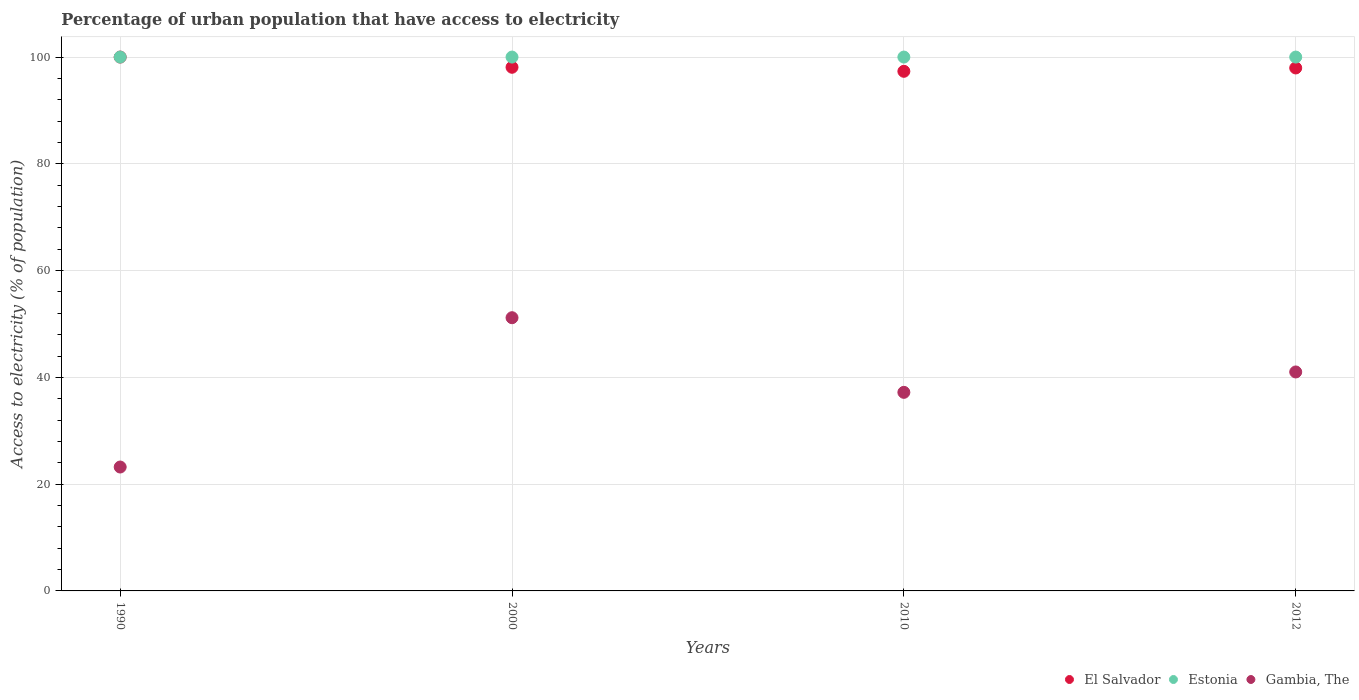Is the number of dotlines equal to the number of legend labels?
Your answer should be very brief. Yes. What is the percentage of urban population that have access to electricity in Gambia, The in 2010?
Provide a succinct answer. 37.2. Across all years, what is the maximum percentage of urban population that have access to electricity in Estonia?
Ensure brevity in your answer.  100. Across all years, what is the minimum percentage of urban population that have access to electricity in El Salvador?
Give a very brief answer. 97.33. In which year was the percentage of urban population that have access to electricity in El Salvador maximum?
Keep it short and to the point. 1990. In which year was the percentage of urban population that have access to electricity in El Salvador minimum?
Your response must be concise. 2010. What is the total percentage of urban population that have access to electricity in El Salvador in the graph?
Your response must be concise. 393.39. What is the difference between the percentage of urban population that have access to electricity in El Salvador in 2000 and that in 2012?
Offer a terse response. 0.13. What is the difference between the percentage of urban population that have access to electricity in Gambia, The in 1990 and the percentage of urban population that have access to electricity in El Salvador in 2000?
Offer a terse response. -74.88. What is the average percentage of urban population that have access to electricity in El Salvador per year?
Your answer should be very brief. 98.35. In the year 2000, what is the difference between the percentage of urban population that have access to electricity in El Salvador and percentage of urban population that have access to electricity in Estonia?
Offer a terse response. -1.91. In how many years, is the percentage of urban population that have access to electricity in Gambia, The greater than 16 %?
Offer a very short reply. 4. What is the ratio of the percentage of urban population that have access to electricity in Estonia in 1990 to that in 2000?
Your answer should be very brief. 1. What is the difference between the highest and the lowest percentage of urban population that have access to electricity in El Salvador?
Your response must be concise. 2.67. In how many years, is the percentage of urban population that have access to electricity in Gambia, The greater than the average percentage of urban population that have access to electricity in Gambia, The taken over all years?
Provide a succinct answer. 2. Is the sum of the percentage of urban population that have access to electricity in El Salvador in 2000 and 2010 greater than the maximum percentage of urban population that have access to electricity in Estonia across all years?
Your answer should be compact. Yes. Is it the case that in every year, the sum of the percentage of urban population that have access to electricity in Estonia and percentage of urban population that have access to electricity in Gambia, The  is greater than the percentage of urban population that have access to electricity in El Salvador?
Make the answer very short. Yes. Is the percentage of urban population that have access to electricity in Estonia strictly greater than the percentage of urban population that have access to electricity in El Salvador over the years?
Keep it short and to the point. No. How many years are there in the graph?
Give a very brief answer. 4. What is the difference between two consecutive major ticks on the Y-axis?
Provide a succinct answer. 20. Are the values on the major ticks of Y-axis written in scientific E-notation?
Your response must be concise. No. Does the graph contain grids?
Give a very brief answer. Yes. How many legend labels are there?
Your response must be concise. 3. What is the title of the graph?
Make the answer very short. Percentage of urban population that have access to electricity. What is the label or title of the Y-axis?
Provide a succinct answer. Access to electricity (% of population). What is the Access to electricity (% of population) of Estonia in 1990?
Your response must be concise. 100. What is the Access to electricity (% of population) in Gambia, The in 1990?
Offer a very short reply. 23.21. What is the Access to electricity (% of population) of El Salvador in 2000?
Provide a succinct answer. 98.09. What is the Access to electricity (% of population) in Gambia, The in 2000?
Offer a terse response. 51.18. What is the Access to electricity (% of population) in El Salvador in 2010?
Give a very brief answer. 97.33. What is the Access to electricity (% of population) of Estonia in 2010?
Offer a very short reply. 100. What is the Access to electricity (% of population) of Gambia, The in 2010?
Your answer should be compact. 37.2. What is the Access to electricity (% of population) in El Salvador in 2012?
Keep it short and to the point. 97.96. What is the Access to electricity (% of population) in Gambia, The in 2012?
Offer a very short reply. 41.01. Across all years, what is the maximum Access to electricity (% of population) of Gambia, The?
Ensure brevity in your answer.  51.18. Across all years, what is the minimum Access to electricity (% of population) in El Salvador?
Provide a short and direct response. 97.33. Across all years, what is the minimum Access to electricity (% of population) of Gambia, The?
Provide a short and direct response. 23.21. What is the total Access to electricity (% of population) of El Salvador in the graph?
Give a very brief answer. 393.39. What is the total Access to electricity (% of population) in Gambia, The in the graph?
Give a very brief answer. 152.6. What is the difference between the Access to electricity (% of population) in El Salvador in 1990 and that in 2000?
Make the answer very short. 1.91. What is the difference between the Access to electricity (% of population) of Gambia, The in 1990 and that in 2000?
Provide a short and direct response. -27.97. What is the difference between the Access to electricity (% of population) in El Salvador in 1990 and that in 2010?
Make the answer very short. 2.67. What is the difference between the Access to electricity (% of population) in Gambia, The in 1990 and that in 2010?
Your answer should be compact. -13.99. What is the difference between the Access to electricity (% of population) in El Salvador in 1990 and that in 2012?
Your response must be concise. 2.04. What is the difference between the Access to electricity (% of population) in Gambia, The in 1990 and that in 2012?
Give a very brief answer. -17.81. What is the difference between the Access to electricity (% of population) of El Salvador in 2000 and that in 2010?
Your answer should be very brief. 0.75. What is the difference between the Access to electricity (% of population) of Estonia in 2000 and that in 2010?
Offer a very short reply. 0. What is the difference between the Access to electricity (% of population) in Gambia, The in 2000 and that in 2010?
Your answer should be compact. 13.98. What is the difference between the Access to electricity (% of population) of El Salvador in 2000 and that in 2012?
Offer a very short reply. 0.13. What is the difference between the Access to electricity (% of population) of Estonia in 2000 and that in 2012?
Provide a succinct answer. 0. What is the difference between the Access to electricity (% of population) of Gambia, The in 2000 and that in 2012?
Offer a very short reply. 10.16. What is the difference between the Access to electricity (% of population) of El Salvador in 2010 and that in 2012?
Provide a succinct answer. -0.63. What is the difference between the Access to electricity (% of population) in Gambia, The in 2010 and that in 2012?
Your response must be concise. -3.82. What is the difference between the Access to electricity (% of population) of El Salvador in 1990 and the Access to electricity (% of population) of Estonia in 2000?
Offer a very short reply. 0. What is the difference between the Access to electricity (% of population) in El Salvador in 1990 and the Access to electricity (% of population) in Gambia, The in 2000?
Ensure brevity in your answer.  48.82. What is the difference between the Access to electricity (% of population) in Estonia in 1990 and the Access to electricity (% of population) in Gambia, The in 2000?
Offer a terse response. 48.82. What is the difference between the Access to electricity (% of population) of El Salvador in 1990 and the Access to electricity (% of population) of Gambia, The in 2010?
Give a very brief answer. 62.8. What is the difference between the Access to electricity (% of population) of Estonia in 1990 and the Access to electricity (% of population) of Gambia, The in 2010?
Your answer should be compact. 62.8. What is the difference between the Access to electricity (% of population) in El Salvador in 1990 and the Access to electricity (% of population) in Estonia in 2012?
Make the answer very short. 0. What is the difference between the Access to electricity (% of population) of El Salvador in 1990 and the Access to electricity (% of population) of Gambia, The in 2012?
Offer a terse response. 58.99. What is the difference between the Access to electricity (% of population) in Estonia in 1990 and the Access to electricity (% of population) in Gambia, The in 2012?
Your answer should be compact. 58.99. What is the difference between the Access to electricity (% of population) in El Salvador in 2000 and the Access to electricity (% of population) in Estonia in 2010?
Ensure brevity in your answer.  -1.91. What is the difference between the Access to electricity (% of population) of El Salvador in 2000 and the Access to electricity (% of population) of Gambia, The in 2010?
Provide a short and direct response. 60.89. What is the difference between the Access to electricity (% of population) of Estonia in 2000 and the Access to electricity (% of population) of Gambia, The in 2010?
Your answer should be compact. 62.8. What is the difference between the Access to electricity (% of population) in El Salvador in 2000 and the Access to electricity (% of population) in Estonia in 2012?
Provide a succinct answer. -1.91. What is the difference between the Access to electricity (% of population) in El Salvador in 2000 and the Access to electricity (% of population) in Gambia, The in 2012?
Your answer should be compact. 57.07. What is the difference between the Access to electricity (% of population) of Estonia in 2000 and the Access to electricity (% of population) of Gambia, The in 2012?
Offer a terse response. 58.99. What is the difference between the Access to electricity (% of population) in El Salvador in 2010 and the Access to electricity (% of population) in Estonia in 2012?
Provide a short and direct response. -2.67. What is the difference between the Access to electricity (% of population) of El Salvador in 2010 and the Access to electricity (% of population) of Gambia, The in 2012?
Your answer should be compact. 56.32. What is the difference between the Access to electricity (% of population) in Estonia in 2010 and the Access to electricity (% of population) in Gambia, The in 2012?
Offer a very short reply. 58.99. What is the average Access to electricity (% of population) in El Salvador per year?
Give a very brief answer. 98.35. What is the average Access to electricity (% of population) of Estonia per year?
Offer a very short reply. 100. What is the average Access to electricity (% of population) in Gambia, The per year?
Ensure brevity in your answer.  38.15. In the year 1990, what is the difference between the Access to electricity (% of population) in El Salvador and Access to electricity (% of population) in Estonia?
Make the answer very short. 0. In the year 1990, what is the difference between the Access to electricity (% of population) in El Salvador and Access to electricity (% of population) in Gambia, The?
Ensure brevity in your answer.  76.79. In the year 1990, what is the difference between the Access to electricity (% of population) of Estonia and Access to electricity (% of population) of Gambia, The?
Make the answer very short. 76.79. In the year 2000, what is the difference between the Access to electricity (% of population) of El Salvador and Access to electricity (% of population) of Estonia?
Give a very brief answer. -1.91. In the year 2000, what is the difference between the Access to electricity (% of population) in El Salvador and Access to electricity (% of population) in Gambia, The?
Ensure brevity in your answer.  46.91. In the year 2000, what is the difference between the Access to electricity (% of population) of Estonia and Access to electricity (% of population) of Gambia, The?
Provide a succinct answer. 48.82. In the year 2010, what is the difference between the Access to electricity (% of population) in El Salvador and Access to electricity (% of population) in Estonia?
Make the answer very short. -2.67. In the year 2010, what is the difference between the Access to electricity (% of population) of El Salvador and Access to electricity (% of population) of Gambia, The?
Your response must be concise. 60.14. In the year 2010, what is the difference between the Access to electricity (% of population) of Estonia and Access to electricity (% of population) of Gambia, The?
Make the answer very short. 62.8. In the year 2012, what is the difference between the Access to electricity (% of population) of El Salvador and Access to electricity (% of population) of Estonia?
Your answer should be very brief. -2.04. In the year 2012, what is the difference between the Access to electricity (% of population) in El Salvador and Access to electricity (% of population) in Gambia, The?
Provide a short and direct response. 56.95. In the year 2012, what is the difference between the Access to electricity (% of population) in Estonia and Access to electricity (% of population) in Gambia, The?
Your answer should be very brief. 58.99. What is the ratio of the Access to electricity (% of population) in El Salvador in 1990 to that in 2000?
Ensure brevity in your answer.  1.02. What is the ratio of the Access to electricity (% of population) of Estonia in 1990 to that in 2000?
Make the answer very short. 1. What is the ratio of the Access to electricity (% of population) of Gambia, The in 1990 to that in 2000?
Give a very brief answer. 0.45. What is the ratio of the Access to electricity (% of population) of El Salvador in 1990 to that in 2010?
Give a very brief answer. 1.03. What is the ratio of the Access to electricity (% of population) of Estonia in 1990 to that in 2010?
Keep it short and to the point. 1. What is the ratio of the Access to electricity (% of population) of Gambia, The in 1990 to that in 2010?
Give a very brief answer. 0.62. What is the ratio of the Access to electricity (% of population) of El Salvador in 1990 to that in 2012?
Your answer should be compact. 1.02. What is the ratio of the Access to electricity (% of population) in Estonia in 1990 to that in 2012?
Give a very brief answer. 1. What is the ratio of the Access to electricity (% of population) in Gambia, The in 1990 to that in 2012?
Your answer should be compact. 0.57. What is the ratio of the Access to electricity (% of population) of Gambia, The in 2000 to that in 2010?
Give a very brief answer. 1.38. What is the ratio of the Access to electricity (% of population) of Estonia in 2000 to that in 2012?
Provide a short and direct response. 1. What is the ratio of the Access to electricity (% of population) in Gambia, The in 2000 to that in 2012?
Provide a succinct answer. 1.25. What is the ratio of the Access to electricity (% of population) in El Salvador in 2010 to that in 2012?
Your answer should be compact. 0.99. What is the ratio of the Access to electricity (% of population) in Gambia, The in 2010 to that in 2012?
Your answer should be compact. 0.91. What is the difference between the highest and the second highest Access to electricity (% of population) in El Salvador?
Offer a very short reply. 1.91. What is the difference between the highest and the second highest Access to electricity (% of population) in Gambia, The?
Provide a short and direct response. 10.16. What is the difference between the highest and the lowest Access to electricity (% of population) in El Salvador?
Offer a terse response. 2.67. What is the difference between the highest and the lowest Access to electricity (% of population) in Estonia?
Ensure brevity in your answer.  0. What is the difference between the highest and the lowest Access to electricity (% of population) in Gambia, The?
Provide a short and direct response. 27.97. 